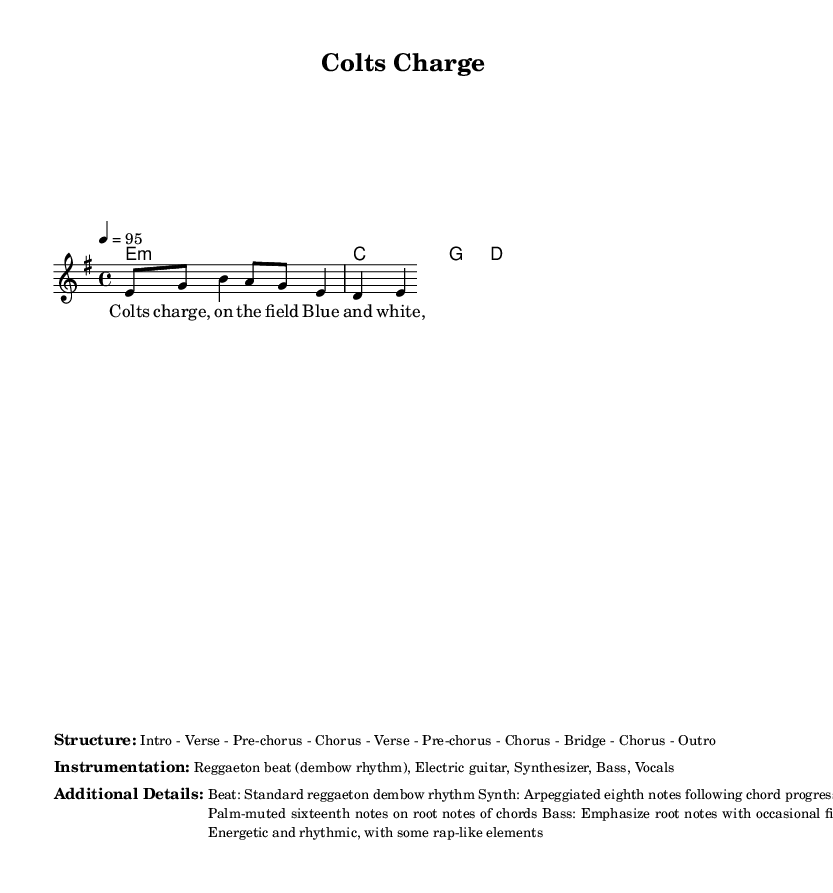What is the key signature of this music? The key signature is E minor, which is indicated by one sharp (F#).
Answer: E minor What is the time signature of this music? The time signature is 4/4, which means there are four beats in each measure and a quarter note gets one beat.
Answer: 4/4 What is the tempo marking for this piece? The tempo marking is set at 95 beats per minute, indicated by "4 = 95."
Answer: 95 How many sections are there in the structure of the piece? The structure includes eleven sections, listed as Intro, Verse, Pre-chorus, Chorus, Verse, Pre-chorus, Chorus, Bridge, Chorus, and Outro.
Answer: Eleven What type of rhythm is used in the instrumentation? The rhythm used in this piece is a standard reggaeton dembow rhythm, which is characteristic of reggaeton music.
Answer: Dembow rhythm What is the primary instrument used for the lead melody? The primary instrument for the lead melody is the electric guitar, as indicated in the instrumentation section.
Answer: Electric guitar What lyrical theme is present in this piece? The lyrical theme revolves around sports and competition, specifically the spirit of the Indianapolis Colts.
Answer: Sports and competition 